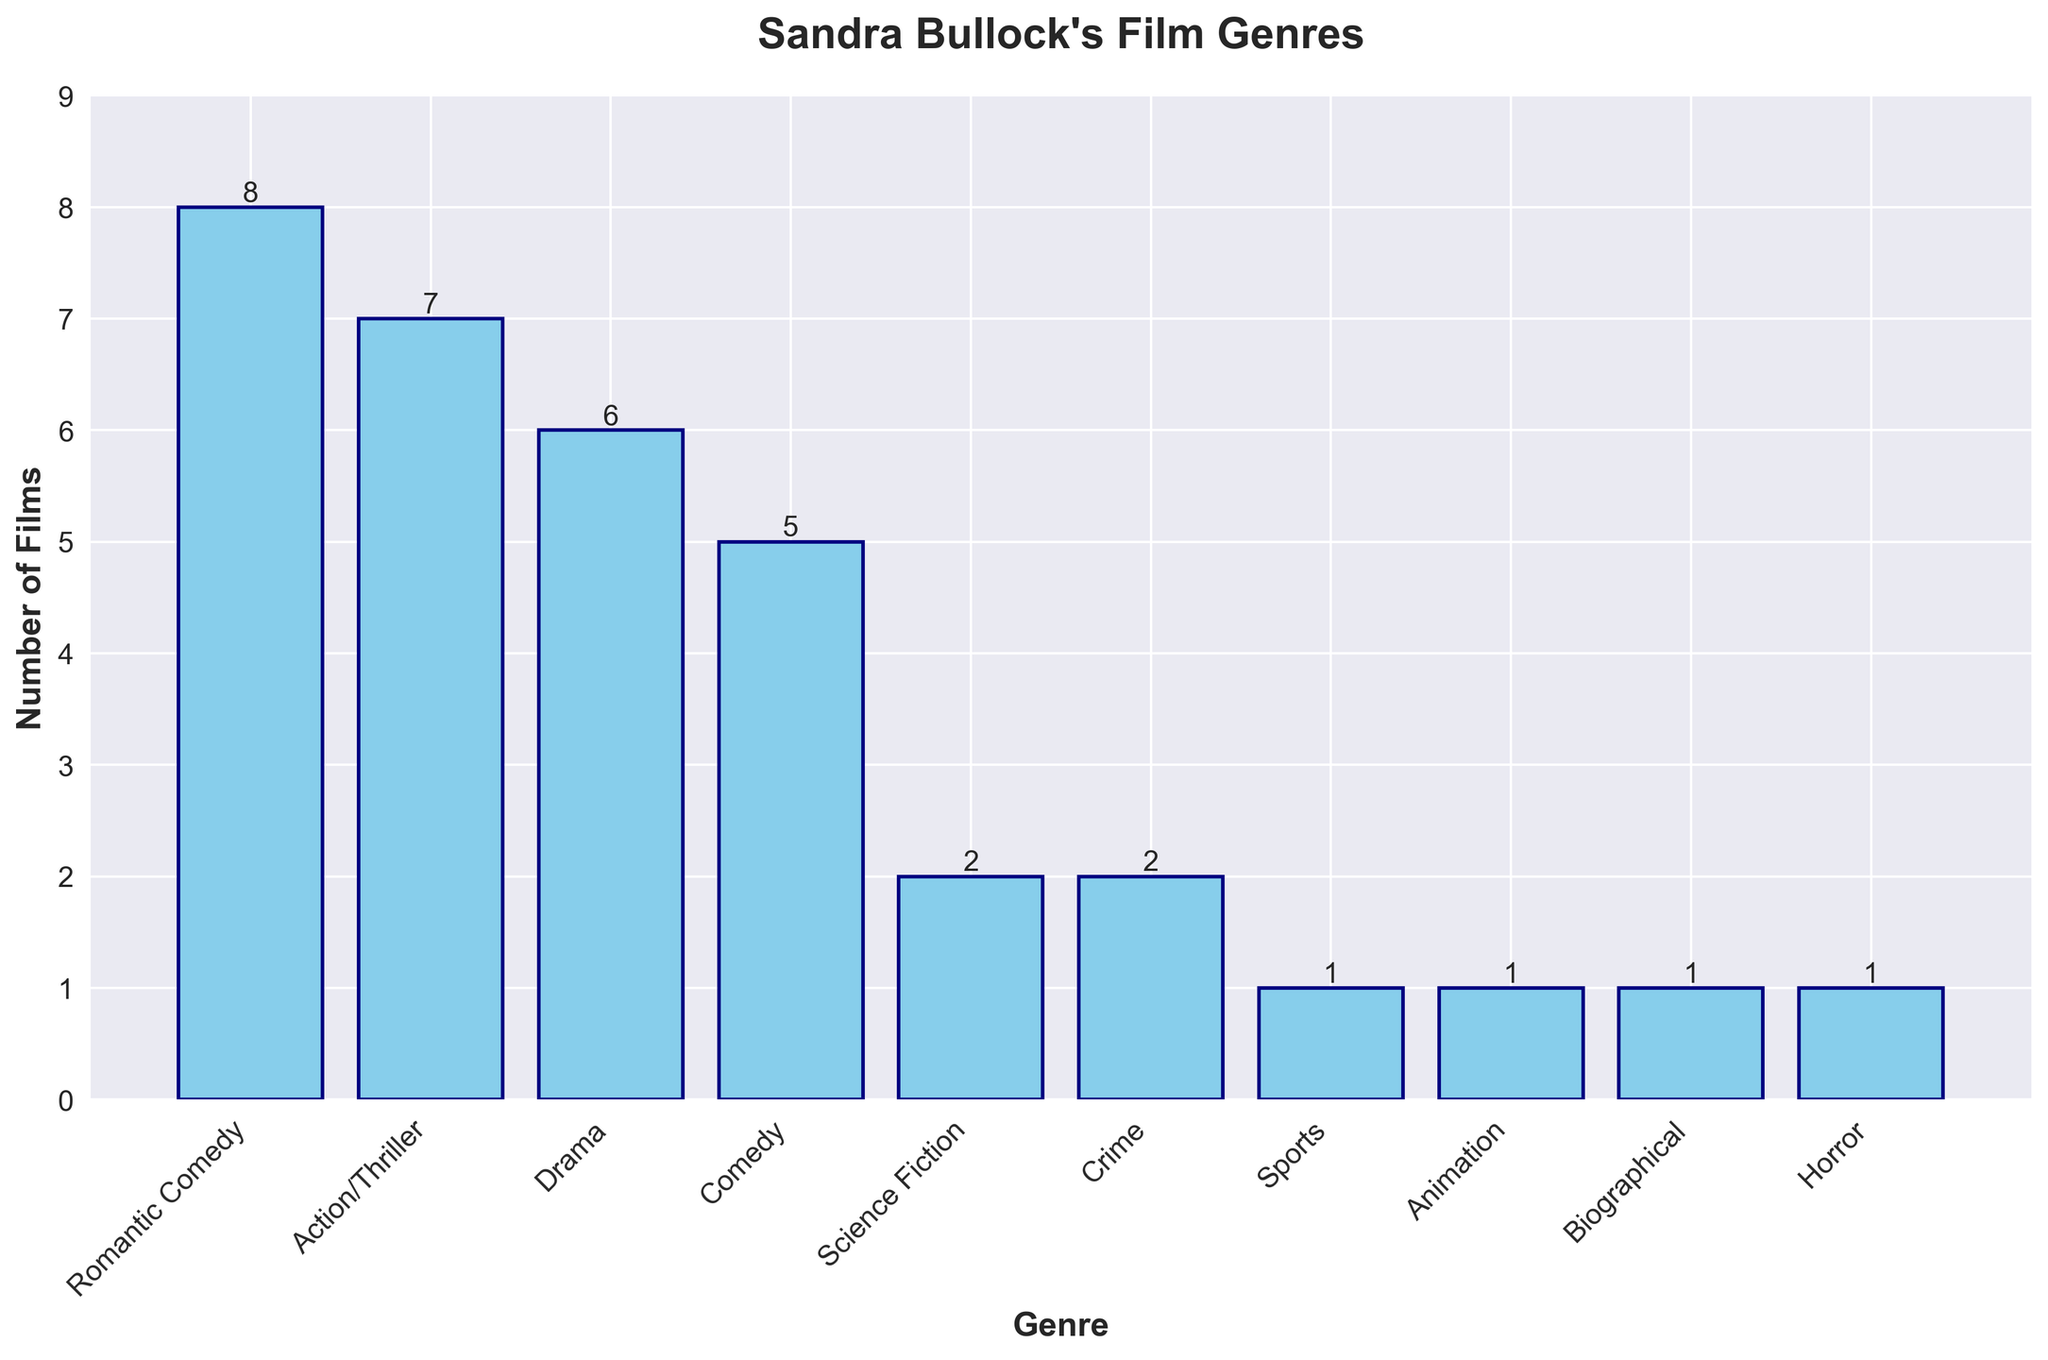What's the most common genre in Sandra Bullock's filmography? The tallest bar in the bar chart represents the most common genre. In this case, the tallest bar corresponds to the 'Romantic Comedy' genre.
Answer: Romantic Comedy How many more Romantic Comedies has Sandra Bullock done compared to Science Fiction films? The bar for Romantic Comedy is at 8, and the bar for Science Fiction is at 2. Subtracting 2 from 8 gives us the difference.
Answer: 6 Which genre has the least number of films, and how many are there? The shortest bars correspond to the least number of films. There are several genres with just 1 film: 'Sports', 'Animation', 'Biographical', and 'Horror'.
Answer: Sports, Animation, Biographical, Horror; 1 What is the total number of films Sandra Bullock has been in across all genres? Add up the heights of all the bars: 8 (Romantic Comedy) + 7 (Action/Thriller) + 6 (Drama) + 5 (Comedy) + 2 (Science Fiction) + 2 (Crime) + 1 (Sports) + 1 (Animation) + 1 (Biographical) + 1 (Horror). This equals 34.
Answer: 34 By how much does the number of Action/Thriller films exceed the number of Comedy films? The bar for Action/Thriller is at 7, and the bar for Comedy is at 5. Subtracting 5 from 7 gives us the difference.
Answer: 2 What percentage of her films are in the Drama genre? Sandra Bullock has 6 Drama films out of a total of 34 films (calculated earlier). The percentage is (6/34) * 100, which is approximately 17.65%.
Answer: 17.65% If Sandra Bullock were to do 3 more Science Fiction films, how would that compare to the number of Romantic Comedy films? Currently, she has 2 Science Fiction films. Adding 3 would make it 5. The number of Romantic Comedy films is 8, so 8 - 5 equals 3. She would still have 3 fewer Science Fiction films compared to Romantic Comedy films.
Answer: 3 fewer Which two genres have the same number of films, and how many are there? The bars for 'Science Fiction' and 'Crime' are both at height 2, indicating that these genres have an equal number of films.
Answer: Science Fiction and Crime; 2 What is the average number of films per genre? There are 10 genres and a total of 34 films. Dividing the total number of films by the number of genres gives the average: 34 / 10 = 3.4.
Answer: 3.4 In which genre does Sandra Bullock have exactly one film, and how many such genres are there? The bars for 'Sports', 'Animation', 'Biographical', and 'Horror' each show exactly 1 film. There are 4 such genres.
Answer: Sports, Animation, Biographical, Horror; 4 